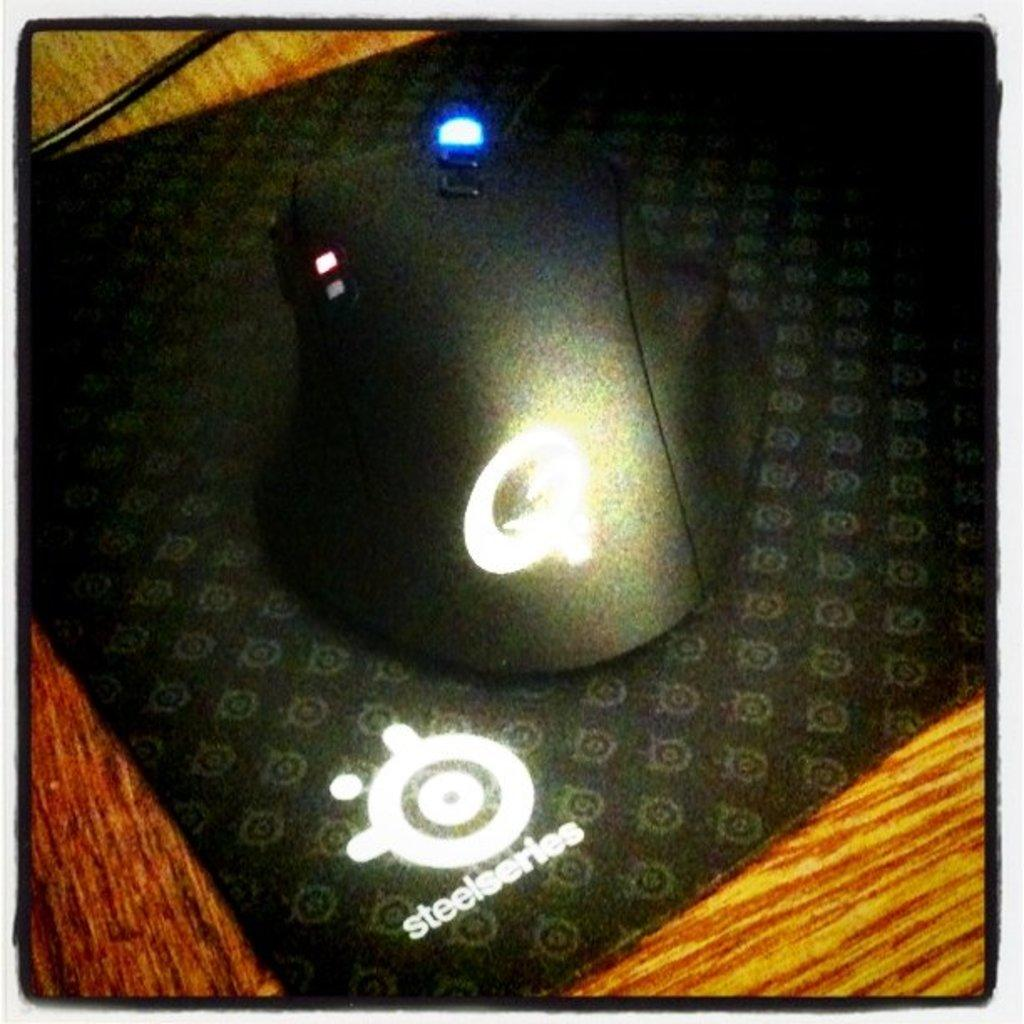Provide a one-sentence caption for the provided image. A mouse and mouse pad that reads Steelseries. 